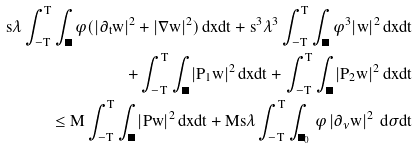<formula> <loc_0><loc_0><loc_500><loc_500>s \lambda \int _ { - T } ^ { T } \int _ { \Omega } \varphi ( | \partial _ { t } w | ^ { 2 } + | \nabla w | ^ { 2 } ) \, d x d t + s ^ { 3 } \lambda ^ { 3 } \int _ { - T } ^ { T } \int _ { \Omega } \varphi ^ { 3 } | w | ^ { 2 } \, d x d t \\ + \int _ { - T } ^ { T } \int _ { \Omega } | P _ { 1 } w | ^ { 2 } \, d x d t + \int _ { - T } ^ { T } \int _ { \Omega } | P _ { 2 } w | ^ { 2 } \, d x d t \\ \leq M \int _ { - T } ^ { T } \int _ { \Omega } | P w | ^ { 2 } \, d x d t + M s \lambda \int _ { - T } ^ { T } \int _ { \Gamma _ { 0 } } \varphi \left | \partial _ { \nu } w \right | ^ { 2 } \, d \sigma d t</formula> 